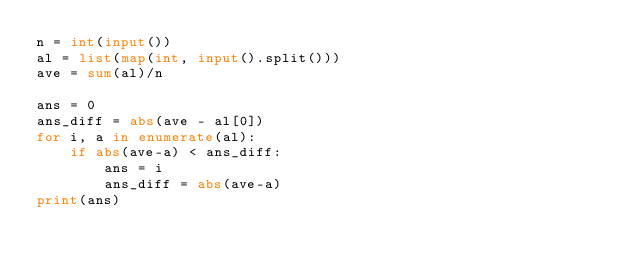<code> <loc_0><loc_0><loc_500><loc_500><_Python_>n = int(input())
al = list(map(int, input().split()))
ave = sum(al)/n

ans = 0
ans_diff = abs(ave - al[0])
for i, a in enumerate(al):
    if abs(ave-a) < ans_diff:
        ans = i
        ans_diff = abs(ave-a)
print(ans)
</code> 